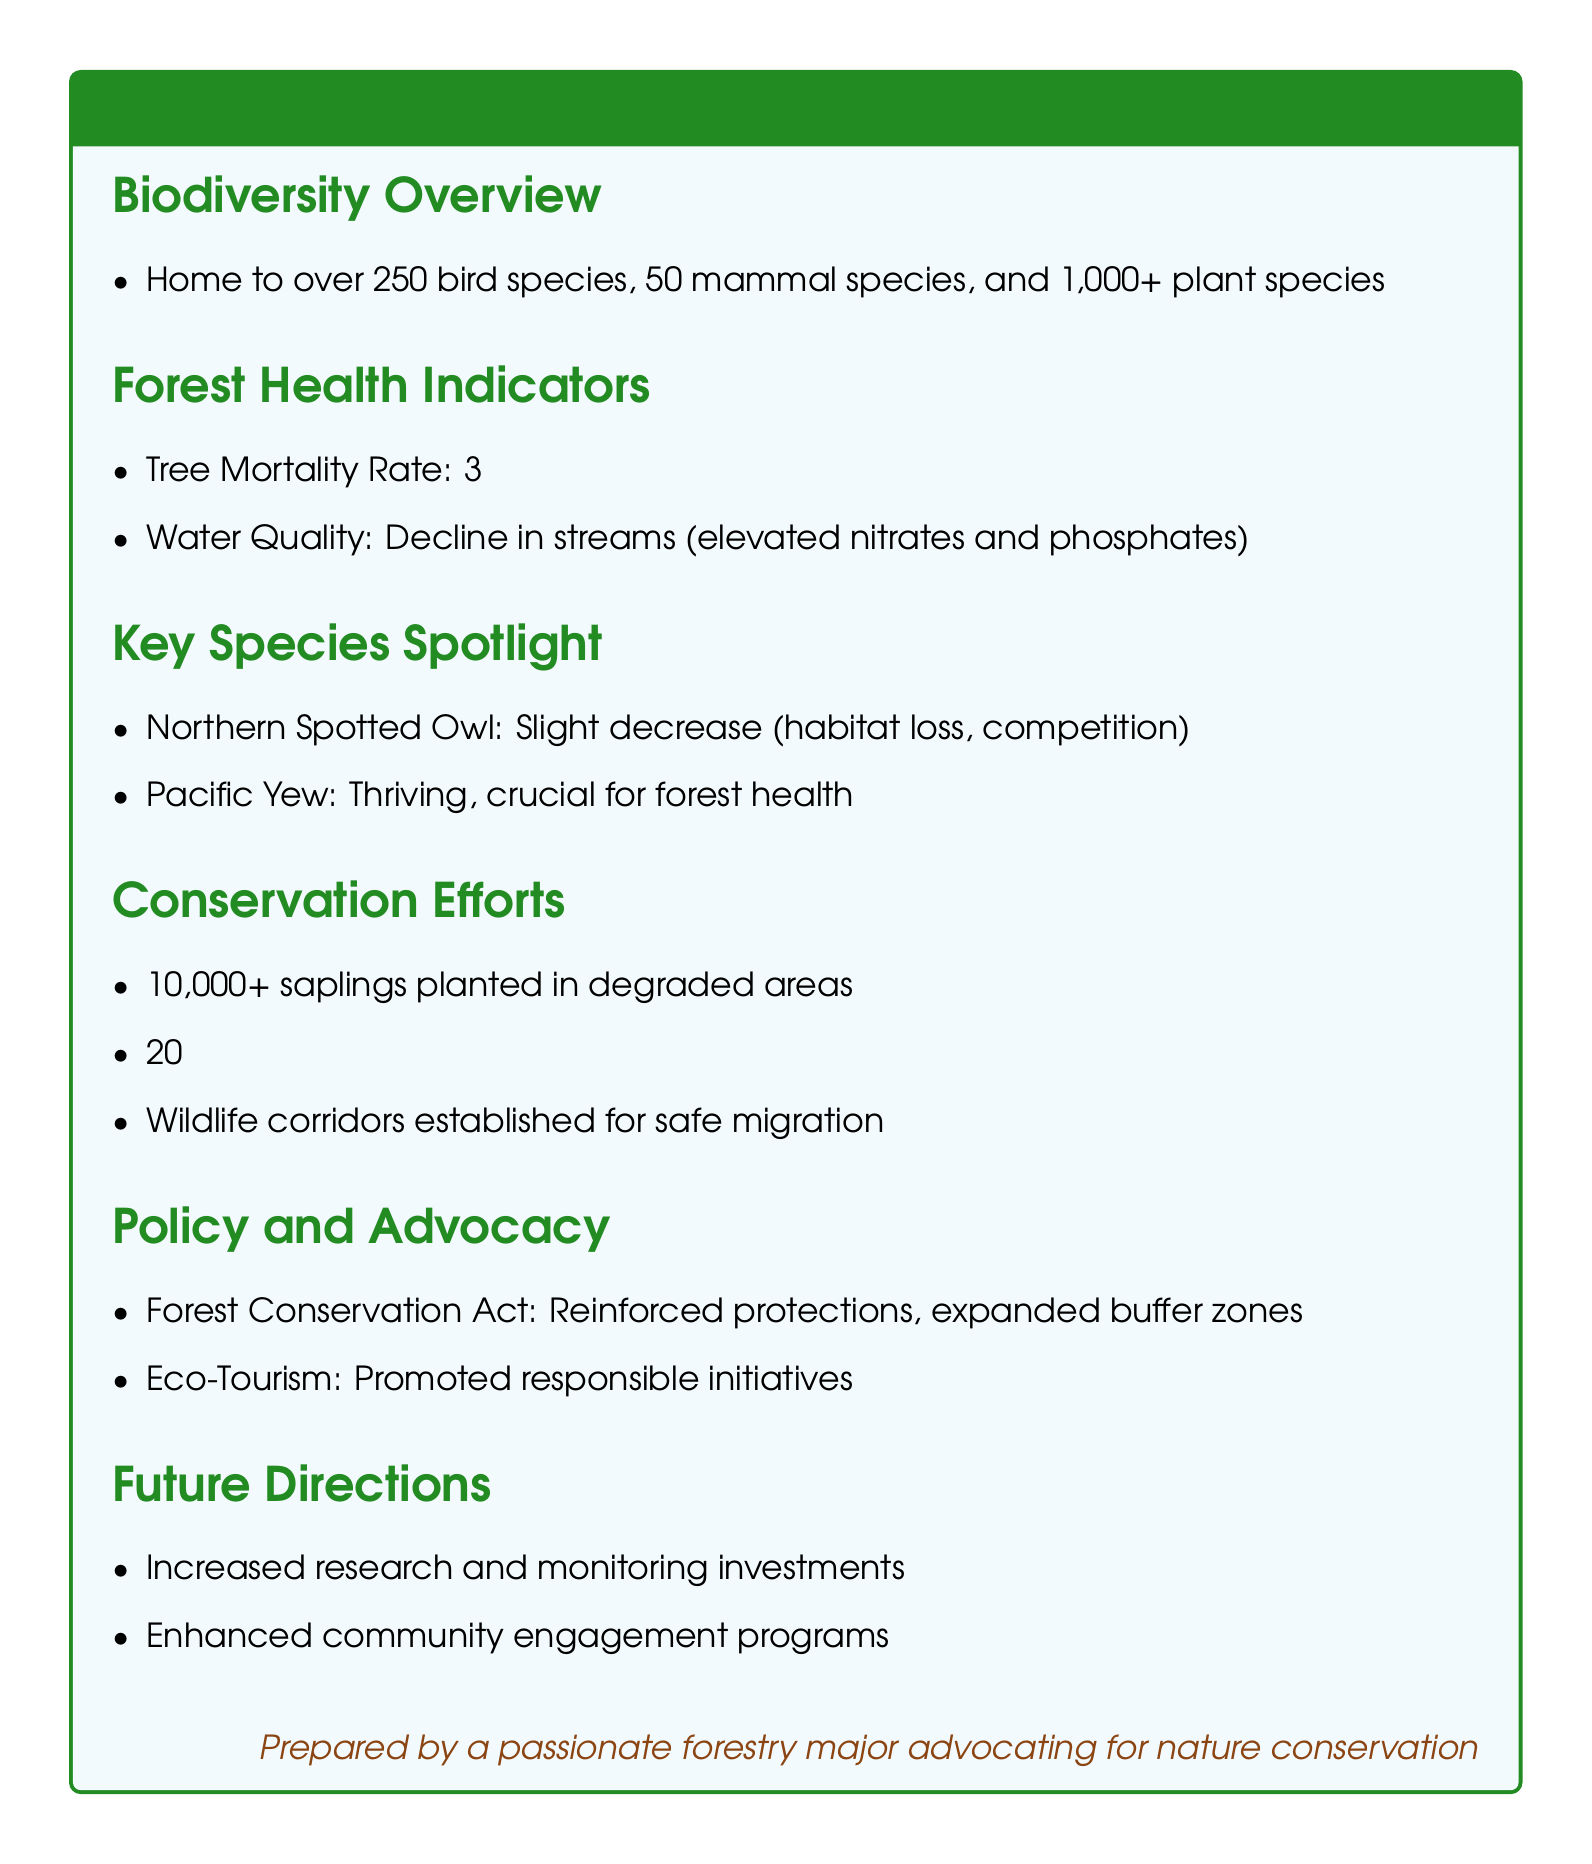What is the total number of plant species? The document states that there are over 1,000+ plant species in the local forests.
Answer: 1,000+ What is the tree mortality rate in 2022? The document indicates that the tree mortality rate in 2022 is 3%.
Answer: 3% Which species has slightly decreased due to habitat loss and competition? The document mentions the Northern Spotted Owl as experiencing a slight decrease due to habitat loss and competition.
Answer: Northern Spotted Owl How many saplings were planted in degraded areas? According to the document, over 10,000 saplings have been planted in degraded areas.
Answer: 10,000+ What percentage reduction in invasive plant species spread was achieved? The document highlights a 20% reduction in the spread of invasive plant species.
Answer: 20% What is a key conservation effort related to wildlife? The document outlines that wildlife corridors were established for safe migration as a key conservation effort.
Answer: Wildlife corridors What legislation reinforced protections for forests? The document refers to the Forest Conservation Act as the legislation that reinforced protections and expanded buffer zones.
Answer: Forest Conservation Act What are the future directions mentioned in the document? The document outlines increased research and monitoring investments and enhanced community engagement programs as future directions.
Answer: Increased research and monitoring investments; enhanced community engagement programs How many mammal species are found in the local forests? The document states that there are 50 mammal species in the local forests.
Answer: 50 